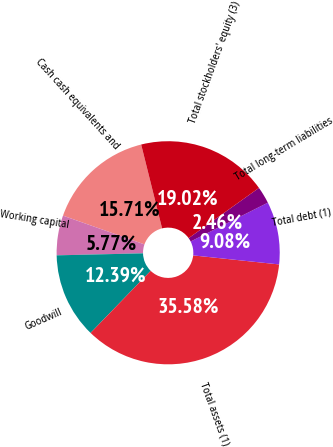Convert chart to OTSL. <chart><loc_0><loc_0><loc_500><loc_500><pie_chart><fcel>Cash cash equivalents and<fcel>Working capital<fcel>Goodwill<fcel>Total assets (1)<fcel>Total debt (1)<fcel>Total long-term liabilities<fcel>Total stockholders' equity (3)<nl><fcel>15.71%<fcel>5.77%<fcel>12.39%<fcel>35.58%<fcel>9.08%<fcel>2.46%<fcel>19.02%<nl></chart> 